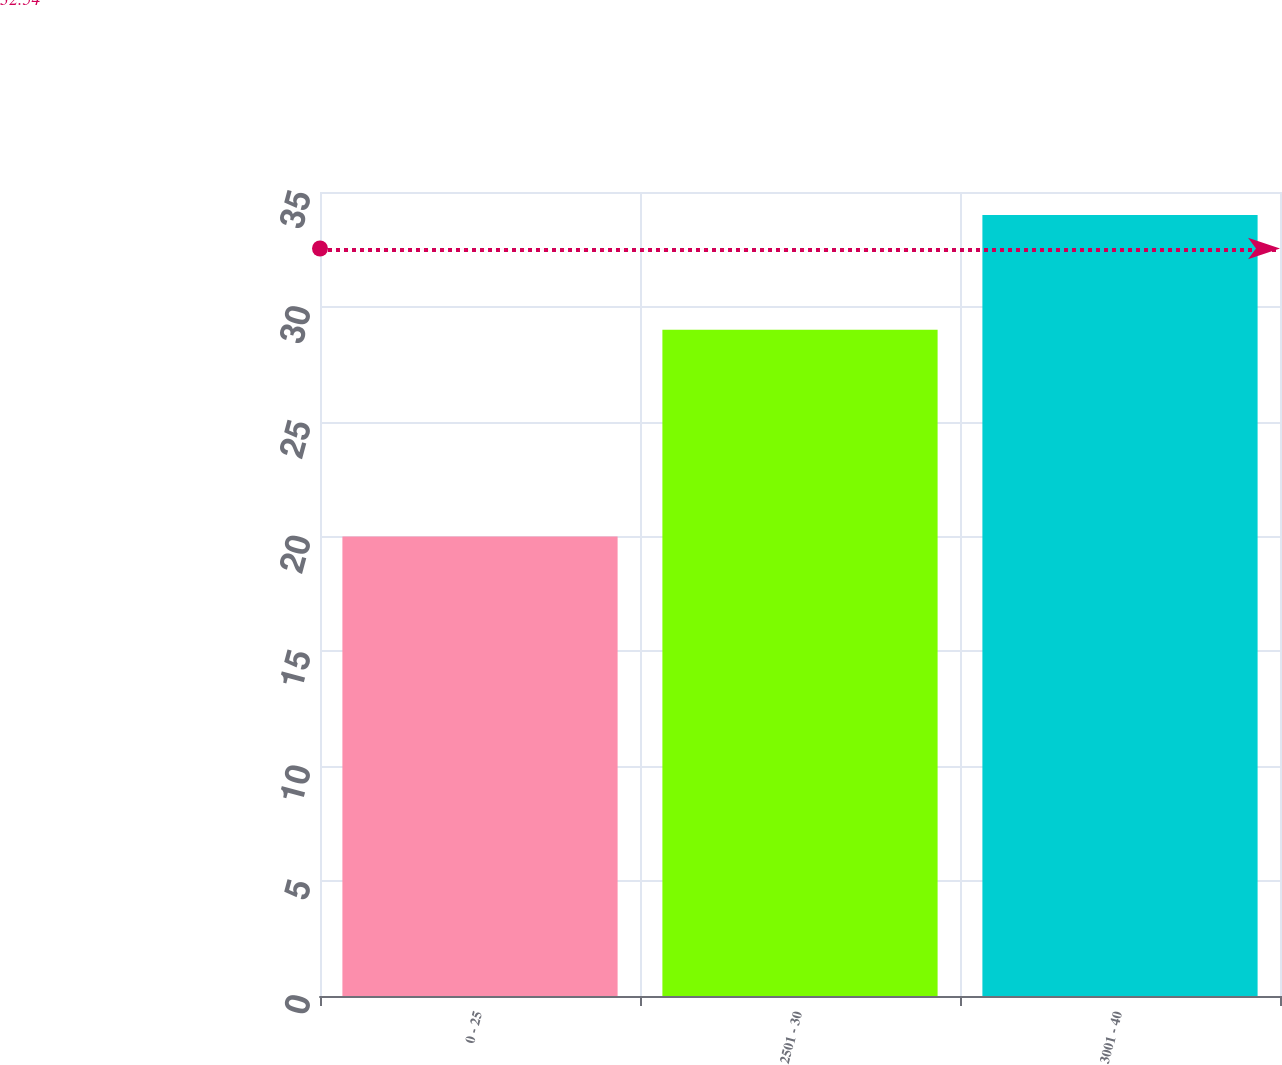Convert chart. <chart><loc_0><loc_0><loc_500><loc_500><bar_chart><fcel>0 - 25<fcel>2501 - 30<fcel>3001 - 40<nl><fcel>20<fcel>29<fcel>34<nl></chart> 